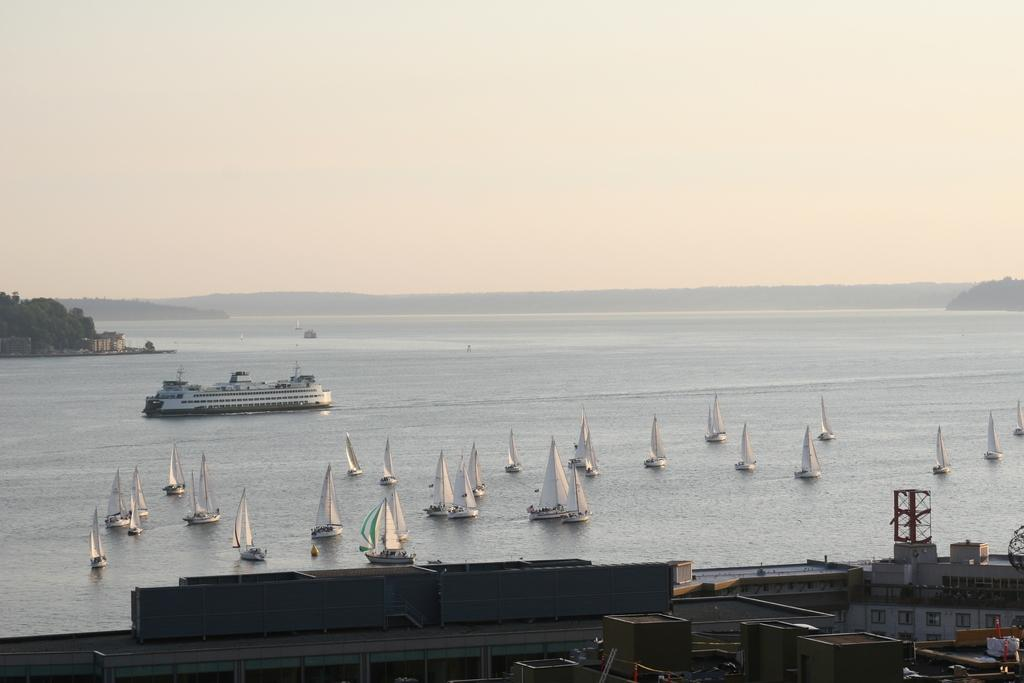What type of structures are present in the image? There are buildings in the image. Where are the buildings located in relation to the image? The buildings are on the bottom side of the image. What else can be seen on the water in the image? There are boats on the water in the image. What is visible in the background of the image? The sky is visible in the background of the image. Where is the mine located in the image? There is no mine present in the image. What type of paper is being used by the giants in the image? There are no giants or paper present in the image. 